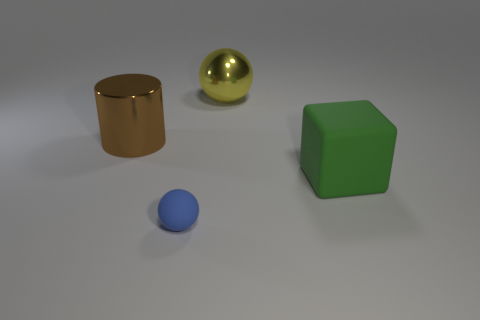Can you describe the atmosphere or mood conveyed by the composition of these objects? The image has a minimalist and clean aesthetic, evoking a sense of order and calm. The cool, neutral background and the soft lighting contribute to a tranquil and serene atmosphere. The arrangement of the objects with ample space around them suggests a structured and balanced environment, perhaps used for a study of shapes and colors. 